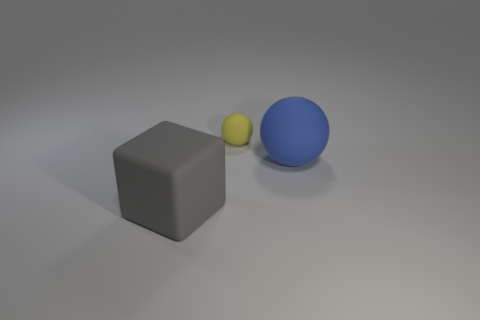Subtract all balls. How many objects are left? 1 Subtract all cyan cubes. How many yellow spheres are left? 1 Add 1 shiny balls. How many objects exist? 4 Subtract all blue rubber things. Subtract all blue balls. How many objects are left? 1 Add 2 yellow objects. How many yellow objects are left? 3 Add 2 cyan matte cylinders. How many cyan matte cylinders exist? 2 Subtract 0 brown blocks. How many objects are left? 3 Subtract 1 blocks. How many blocks are left? 0 Subtract all yellow balls. Subtract all purple cylinders. How many balls are left? 1 